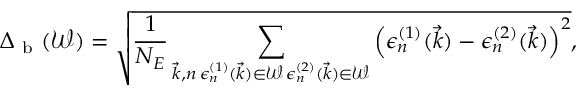<formula> <loc_0><loc_0><loc_500><loc_500>\Delta _ { b } ( \mathcal { W } ) = \sqrt { \frac { 1 } { N _ { E } } \sum _ { \substack { \vec { k } , n \, \epsilon _ { n } ^ { ( 1 ) } ( \vec { k } ) \in \mathcal { W } \, \epsilon _ { n } ^ { ( 2 ) } ( \vec { k } ) \in \mathcal { W } } } \left ( \epsilon _ { n } ^ { ( 1 ) } ( \vec { k } ) - \epsilon _ { n } ^ { ( 2 ) } ( \vec { k } ) \right ) ^ { 2 } } ,</formula> 